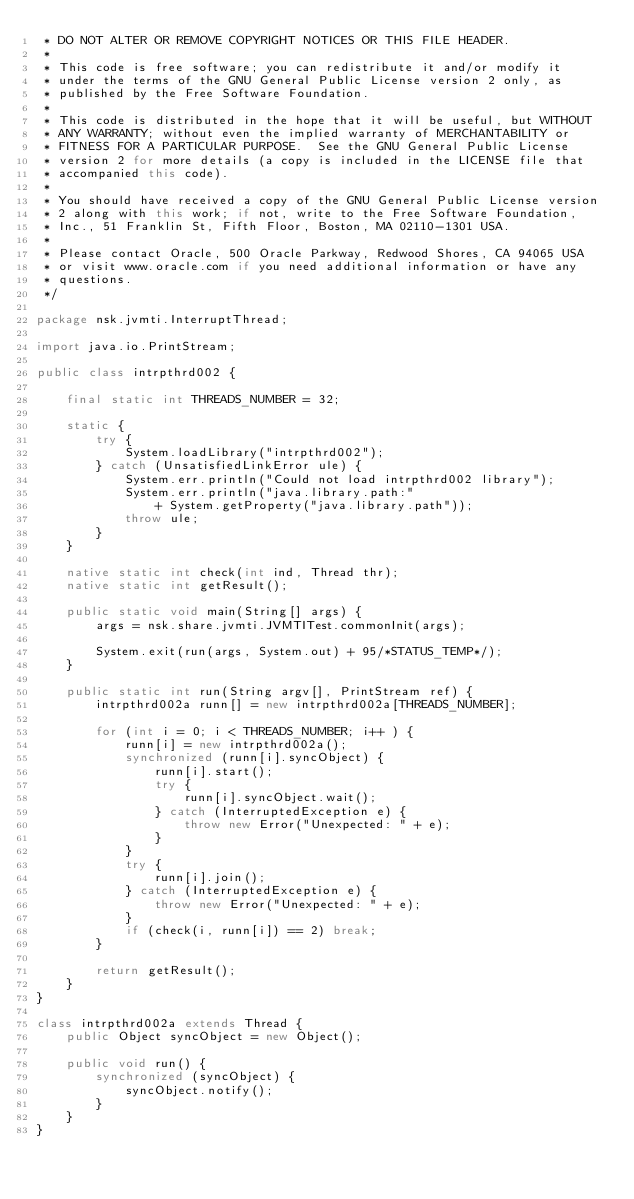<code> <loc_0><loc_0><loc_500><loc_500><_Java_> * DO NOT ALTER OR REMOVE COPYRIGHT NOTICES OR THIS FILE HEADER.
 *
 * This code is free software; you can redistribute it and/or modify it
 * under the terms of the GNU General Public License version 2 only, as
 * published by the Free Software Foundation.
 *
 * This code is distributed in the hope that it will be useful, but WITHOUT
 * ANY WARRANTY; without even the implied warranty of MERCHANTABILITY or
 * FITNESS FOR A PARTICULAR PURPOSE.  See the GNU General Public License
 * version 2 for more details (a copy is included in the LICENSE file that
 * accompanied this code).
 *
 * You should have received a copy of the GNU General Public License version
 * 2 along with this work; if not, write to the Free Software Foundation,
 * Inc., 51 Franklin St, Fifth Floor, Boston, MA 02110-1301 USA.
 *
 * Please contact Oracle, 500 Oracle Parkway, Redwood Shores, CA 94065 USA
 * or visit www.oracle.com if you need additional information or have any
 * questions.
 */

package nsk.jvmti.InterruptThread;

import java.io.PrintStream;

public class intrpthrd002 {

    final static int THREADS_NUMBER = 32;

    static {
        try {
            System.loadLibrary("intrpthrd002");
        } catch (UnsatisfiedLinkError ule) {
            System.err.println("Could not load intrpthrd002 library");
            System.err.println("java.library.path:"
                + System.getProperty("java.library.path"));
            throw ule;
        }
    }

    native static int check(int ind, Thread thr);
    native static int getResult();

    public static void main(String[] args) {
        args = nsk.share.jvmti.JVMTITest.commonInit(args);

        System.exit(run(args, System.out) + 95/*STATUS_TEMP*/);
    }

    public static int run(String argv[], PrintStream ref) {
        intrpthrd002a runn[] = new intrpthrd002a[THREADS_NUMBER];

        for (int i = 0; i < THREADS_NUMBER; i++ ) {
            runn[i] = new intrpthrd002a();
            synchronized (runn[i].syncObject) {
                runn[i].start();
                try {
                    runn[i].syncObject.wait();
                } catch (InterruptedException e) {
                    throw new Error("Unexpected: " + e);
                }
            }
            try {
                runn[i].join();
            } catch (InterruptedException e) {
                throw new Error("Unexpected: " + e);
            }
            if (check(i, runn[i]) == 2) break;
        }

        return getResult();
    }
}

class intrpthrd002a extends Thread {
    public Object syncObject = new Object();

    public void run() {
        synchronized (syncObject) {
            syncObject.notify();
        }
    }
}
</code> 